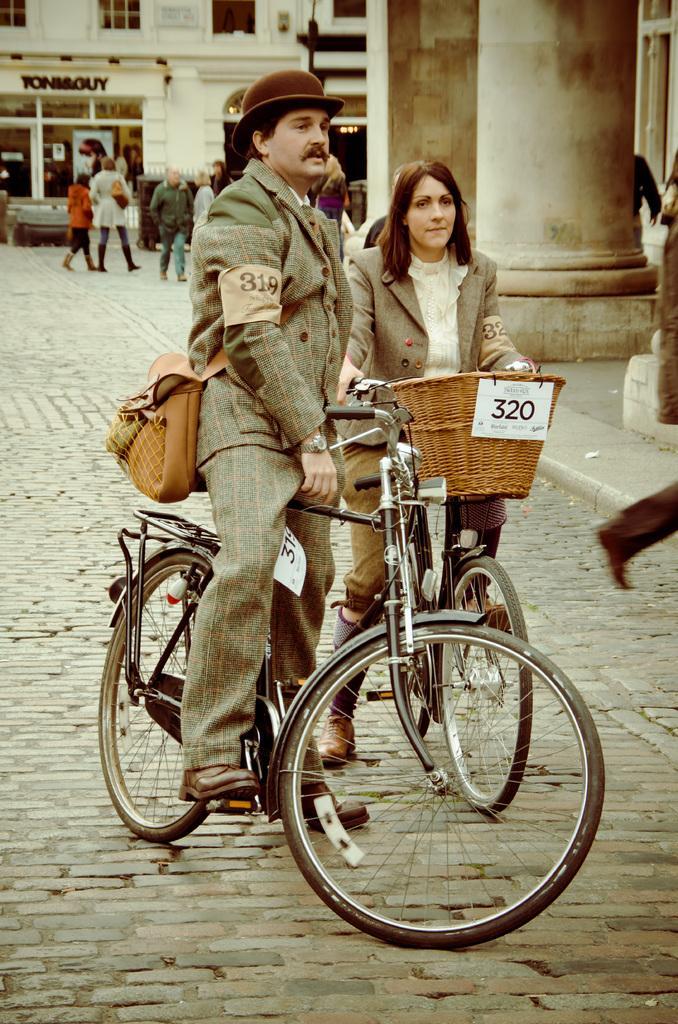Please provide a concise description of this image. It is a picture taken from a street a man is standing on a cycle,he is wearing a brown color bag, beside him there is another woman she is also on cycle behind them there are few people walking on the path, in the background there is a Toni and Guy showroom and a big building and some pillars. 